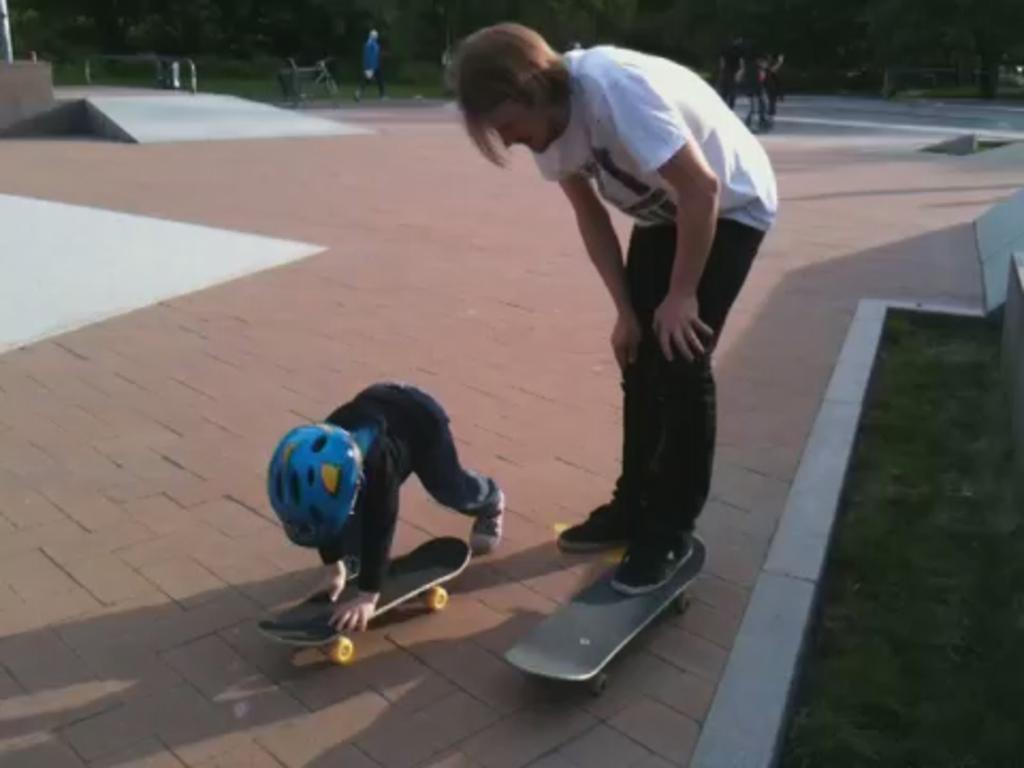Describe this image in one or two sentences. In this image we can see a man is standing on the road and kept one of his leg on a skateboard which is on the road and beside him there is a kid in motion holding a skateboard with the hands which is on the road. On the right side we can see grass on the ground. In the background we can see few persons are walking on the road, trees and a bicycle. 